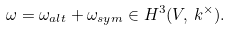<formula> <loc_0><loc_0><loc_500><loc_500>\omega = \omega _ { a l t } + \omega _ { s y m } \in H ^ { 3 } ( V , \, k ^ { \times } ) .</formula> 